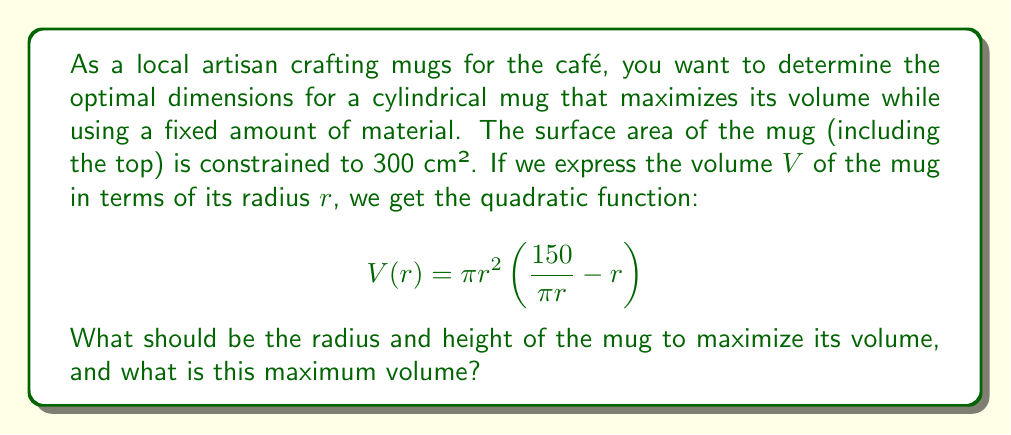Show me your answer to this math problem. Let's approach this step-by-step:

1) First, we need to expand the volume function:
   $$V(r) = \pi r^2 (\frac{150}{\pi r} - r) = 150r - \pi r^3$$

2) To find the maximum volume, we need to find where the derivative of $V(r)$ equals zero:
   $$V'(r) = 150 - 3\pi r^2$$
   $$150 - 3\pi r^2 = 0$$

3) Solving for $r$:
   $$3\pi r^2 = 150$$
   $$r^2 = \frac{50}{\pi}$$
   $$r = \sqrt{\frac{50}{\pi}} \approx 3.99 \text{ cm}$$

4) To find the height $h$, we can use the surface area formula:
   $$300 = 2\pi r^2 + 2\pi rh$$
   $$300 = 2\pi(\frac{50}{\pi}) + 2\pi r h$$
   $$300 = 100 + 2\pi r h$$
   $$h = \frac{200}{2\pi r} = \frac{100}{\pi r} \approx 7.98 \text{ cm}$$

5) The maximum volume can be calculated by substituting $r$ back into the original volume function:
   $$V(r) = 150r - \pi r^3$$
   $$V(\sqrt{\frac{50}{\pi}}) = 150\sqrt{\frac{50}{\pi}} - \pi (\frac{50}{\pi})^{\frac{3}{2}}$$
   $$= 150\sqrt{\frac{50}{\pi}} - 50\sqrt{\frac{50}{\pi}}$$
   $$= 100\sqrt{\frac{50}{\pi}} \approx 399.07 \text{ cm}^3$$
Answer: The optimal dimensions for the mug are:
Radius ≈ 3.99 cm
Height ≈ 7.98 cm
Maximum volume ≈ 399.07 cm³ 